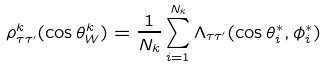<formula> <loc_0><loc_0><loc_500><loc_500>\rho ^ { k } _ { \tau \tau ^ { \prime } } ( \cos \theta ^ { k } _ { W } ) = \frac { 1 } { N _ { k } } \sum _ { i = 1 } ^ { N _ { k } } \Lambda _ { \tau \tau ^ { \prime } } ( \cos \theta _ { i } ^ { * } , \phi _ { i } ^ { * } )</formula> 